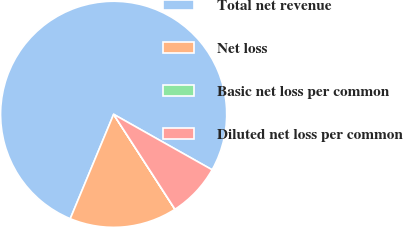Convert chart. <chart><loc_0><loc_0><loc_500><loc_500><pie_chart><fcel>Total net revenue<fcel>Net loss<fcel>Basic net loss per common<fcel>Diluted net loss per common<nl><fcel>76.89%<fcel>15.39%<fcel>0.01%<fcel>7.7%<nl></chart> 